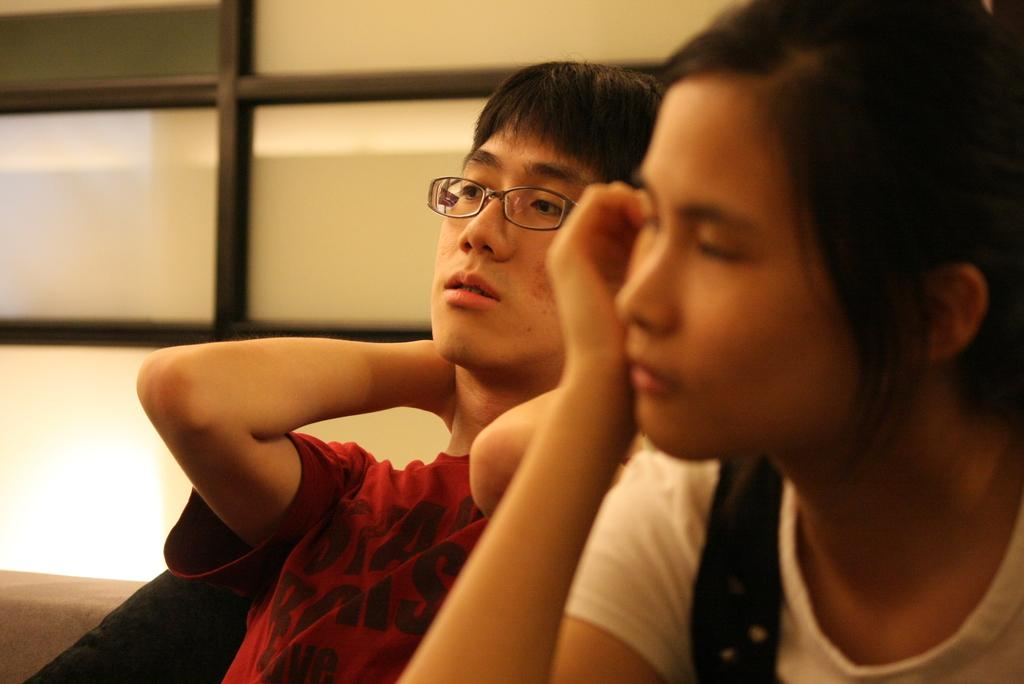How many people are present in the image? There are two people in the image, a man and a woman. What are the man and woman doing in the image? The man and woman are sitting. What can be seen through the window in the image? The facts do not specify what can be seen through the window, so we cannot answer that question definitively. What type of thrill can be seen on the faces of the man and woman in the image? There is no indication of any thrill or emotion on the faces of the man and woman in the image, as their expressions are not described in the facts. --- Facts: 1. There is a car in the image. 2. The car is red. 3. The car has four wheels. 4. There is a road visible in the image. Absurd Topics: parrot, ocean, dance Conversation: What is the color of the car in the image? The car is red. How many wheels does the car have? The car has four wheels. What can be seen in the background of the image? There is a road visible in the image. Reasoning: Let's think step by step in order to produce the conversation. We start by identifying the main subject in the image, which is the car. Then, we describe its color and the number of wheels it has. Finally, we mention the presence of a road in the background, which is the only detail provided about the setting. Absurd Question/Answer: Can you see a parrot flying over the car in the image? There is no mention of a parrot in the image, so we cannot answer that question definitively. --- Facts: 1. There is a dog in the image. 2. The dog is brown. 3. The dog is sitting. 4. There is a fence in the image. Absurd Topics: rainbow, piano, jump Conversation: What type of animal is in the image? There is a dog in the image. What color is the dog? The dog is brown. What is the dog doing in the image? The dog is sitting. What can be seen in the background of the image? There is a fence in the image. Reasoning: Let's think step by step in order to produce the conversation. We start by identifying the main subject in the image, which is the dog. Then, we describe its color and the action it is performing. Finally, we mention the presence of a fence in the background, which is the only detail provided about the setting. Absurd Question/Answer: Can you hear the dog playing the piano in the image? There is no mention of a piano or any sound in the image, so we cannot answer that question definitively. 